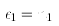Convert formula to latex. <formula><loc_0><loc_0><loc_500><loc_500>\epsilon _ { 1 } = n _ { 1 }</formula> 